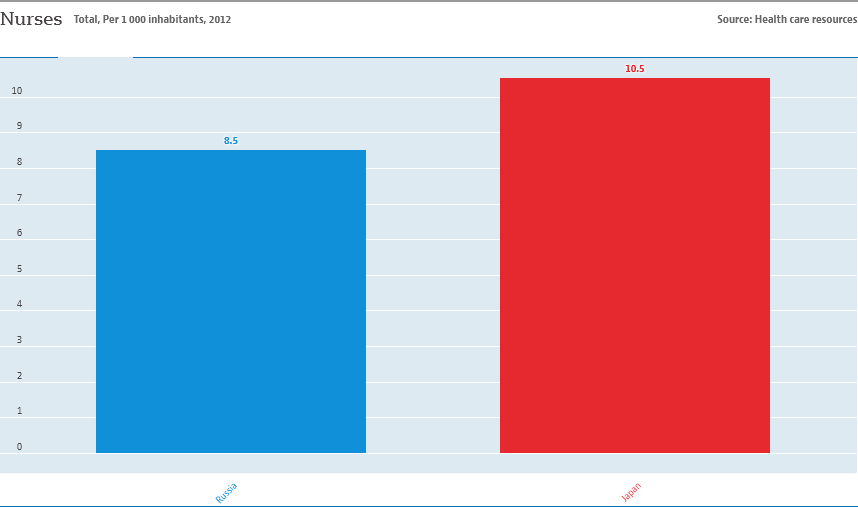Outline some significant characteristics in this image. Japan has a higher number of nurses per 1000 inhabitants compared to other countries. The median and average value of two bars are greater than 9, as indicated by the answer "Yes. 